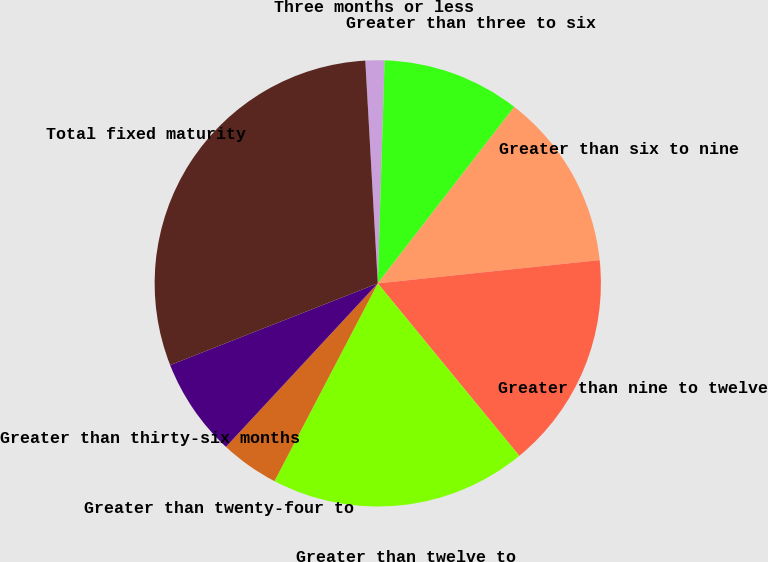Convert chart to OTSL. <chart><loc_0><loc_0><loc_500><loc_500><pie_chart><fcel>Three months or less<fcel>Greater than three to six<fcel>Greater than six to nine<fcel>Greater than nine to twelve<fcel>Greater than twelve to<fcel>Greater than twenty-four to<fcel>Greater than thirty-six months<fcel>Total fixed maturity<nl><fcel>1.38%<fcel>9.99%<fcel>12.86%<fcel>15.73%<fcel>18.6%<fcel>4.25%<fcel>7.12%<fcel>30.08%<nl></chart> 